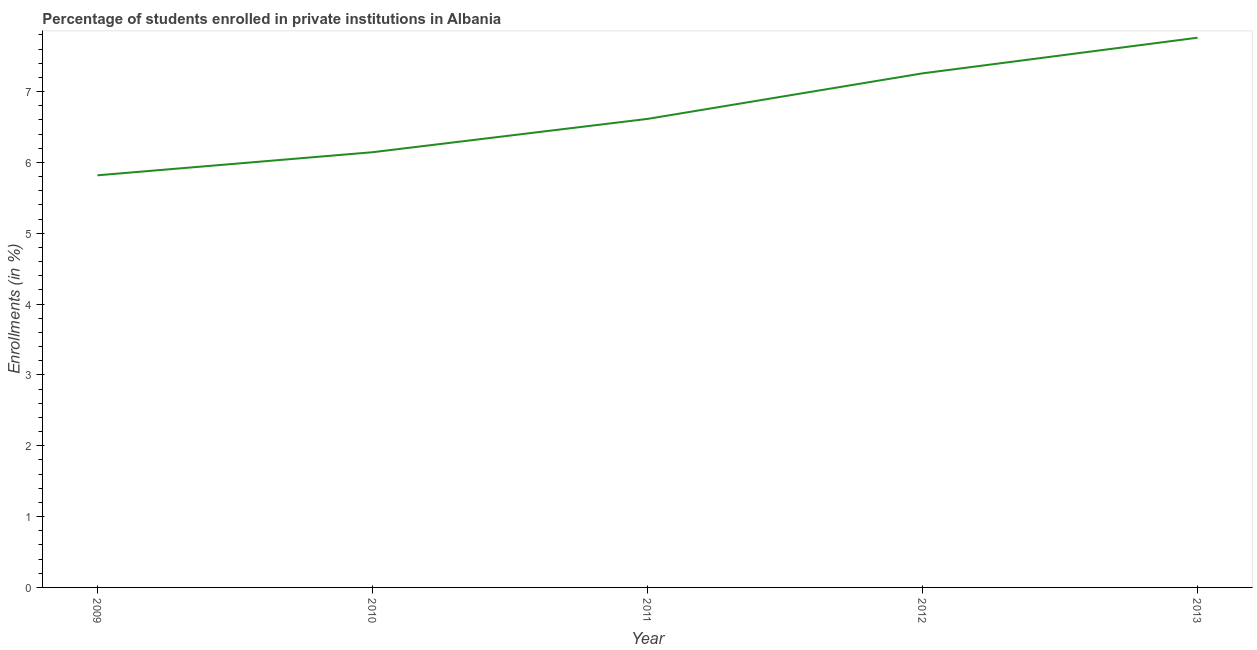What is the enrollments in private institutions in 2013?
Your answer should be very brief. 7.76. Across all years, what is the maximum enrollments in private institutions?
Keep it short and to the point. 7.76. Across all years, what is the minimum enrollments in private institutions?
Make the answer very short. 5.82. In which year was the enrollments in private institutions maximum?
Ensure brevity in your answer.  2013. In which year was the enrollments in private institutions minimum?
Ensure brevity in your answer.  2009. What is the sum of the enrollments in private institutions?
Keep it short and to the point. 33.6. What is the difference between the enrollments in private institutions in 2012 and 2013?
Your response must be concise. -0.5. What is the average enrollments in private institutions per year?
Ensure brevity in your answer.  6.72. What is the median enrollments in private institutions?
Provide a short and direct response. 6.61. Do a majority of the years between 2009 and 2011 (inclusive) have enrollments in private institutions greater than 2.2 %?
Your answer should be very brief. Yes. What is the ratio of the enrollments in private institutions in 2011 to that in 2013?
Keep it short and to the point. 0.85. Is the enrollments in private institutions in 2009 less than that in 2012?
Offer a terse response. Yes. What is the difference between the highest and the second highest enrollments in private institutions?
Ensure brevity in your answer.  0.5. Is the sum of the enrollments in private institutions in 2010 and 2013 greater than the maximum enrollments in private institutions across all years?
Offer a very short reply. Yes. What is the difference between the highest and the lowest enrollments in private institutions?
Your answer should be very brief. 1.94. Does the enrollments in private institutions monotonically increase over the years?
Your response must be concise. Yes. How many lines are there?
Ensure brevity in your answer.  1. How many years are there in the graph?
Your answer should be compact. 5. What is the difference between two consecutive major ticks on the Y-axis?
Your answer should be very brief. 1. Are the values on the major ticks of Y-axis written in scientific E-notation?
Provide a short and direct response. No. Does the graph contain any zero values?
Keep it short and to the point. No. Does the graph contain grids?
Provide a short and direct response. No. What is the title of the graph?
Keep it short and to the point. Percentage of students enrolled in private institutions in Albania. What is the label or title of the X-axis?
Ensure brevity in your answer.  Year. What is the label or title of the Y-axis?
Your response must be concise. Enrollments (in %). What is the Enrollments (in %) in 2009?
Your response must be concise. 5.82. What is the Enrollments (in %) of 2010?
Ensure brevity in your answer.  6.14. What is the Enrollments (in %) of 2011?
Your answer should be compact. 6.61. What is the Enrollments (in %) in 2012?
Keep it short and to the point. 7.26. What is the Enrollments (in %) of 2013?
Offer a very short reply. 7.76. What is the difference between the Enrollments (in %) in 2009 and 2010?
Your answer should be compact. -0.33. What is the difference between the Enrollments (in %) in 2009 and 2011?
Give a very brief answer. -0.8. What is the difference between the Enrollments (in %) in 2009 and 2012?
Offer a very short reply. -1.44. What is the difference between the Enrollments (in %) in 2009 and 2013?
Your answer should be very brief. -1.94. What is the difference between the Enrollments (in %) in 2010 and 2011?
Ensure brevity in your answer.  -0.47. What is the difference between the Enrollments (in %) in 2010 and 2012?
Provide a short and direct response. -1.11. What is the difference between the Enrollments (in %) in 2010 and 2013?
Keep it short and to the point. -1.62. What is the difference between the Enrollments (in %) in 2011 and 2012?
Provide a short and direct response. -0.64. What is the difference between the Enrollments (in %) in 2011 and 2013?
Make the answer very short. -1.15. What is the difference between the Enrollments (in %) in 2012 and 2013?
Your answer should be very brief. -0.5. What is the ratio of the Enrollments (in %) in 2009 to that in 2010?
Make the answer very short. 0.95. What is the ratio of the Enrollments (in %) in 2009 to that in 2012?
Provide a succinct answer. 0.8. What is the ratio of the Enrollments (in %) in 2010 to that in 2011?
Your answer should be very brief. 0.93. What is the ratio of the Enrollments (in %) in 2010 to that in 2012?
Keep it short and to the point. 0.85. What is the ratio of the Enrollments (in %) in 2010 to that in 2013?
Give a very brief answer. 0.79. What is the ratio of the Enrollments (in %) in 2011 to that in 2012?
Give a very brief answer. 0.91. What is the ratio of the Enrollments (in %) in 2011 to that in 2013?
Provide a short and direct response. 0.85. What is the ratio of the Enrollments (in %) in 2012 to that in 2013?
Make the answer very short. 0.94. 